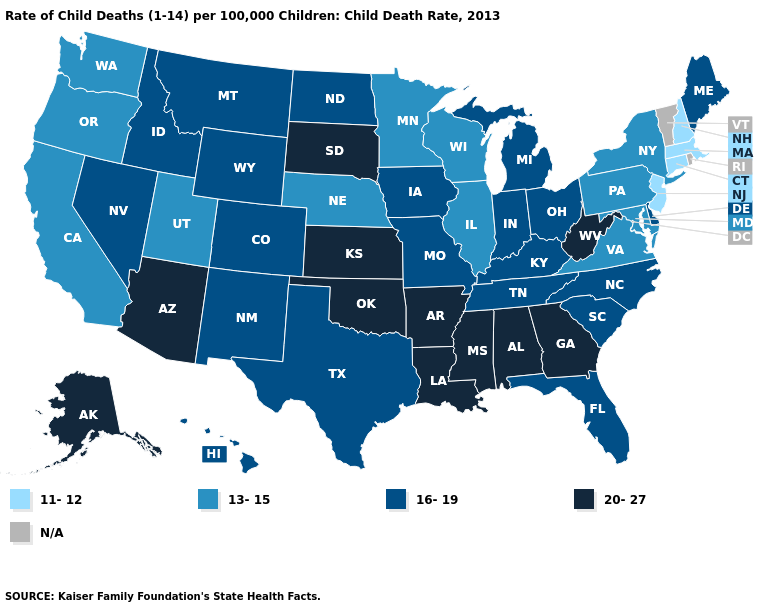What is the value of Virginia?
Keep it brief. 13-15. What is the highest value in the USA?
Quick response, please. 20-27. Does Kansas have the highest value in the USA?
Concise answer only. Yes. Does Texas have the highest value in the USA?
Be succinct. No. Which states have the lowest value in the South?
Concise answer only. Maryland, Virginia. Does the first symbol in the legend represent the smallest category?
Give a very brief answer. Yes. Does Virginia have the highest value in the South?
Answer briefly. No. What is the value of Washington?
Concise answer only. 13-15. What is the value of Iowa?
Write a very short answer. 16-19. What is the value of North Dakota?
Keep it brief. 16-19. Which states have the highest value in the USA?
Quick response, please. Alabama, Alaska, Arizona, Arkansas, Georgia, Kansas, Louisiana, Mississippi, Oklahoma, South Dakota, West Virginia. Does Maine have the highest value in the Northeast?
Write a very short answer. Yes. Name the states that have a value in the range 16-19?
Short answer required. Colorado, Delaware, Florida, Hawaii, Idaho, Indiana, Iowa, Kentucky, Maine, Michigan, Missouri, Montana, Nevada, New Mexico, North Carolina, North Dakota, Ohio, South Carolina, Tennessee, Texas, Wyoming. Is the legend a continuous bar?
Concise answer only. No. 